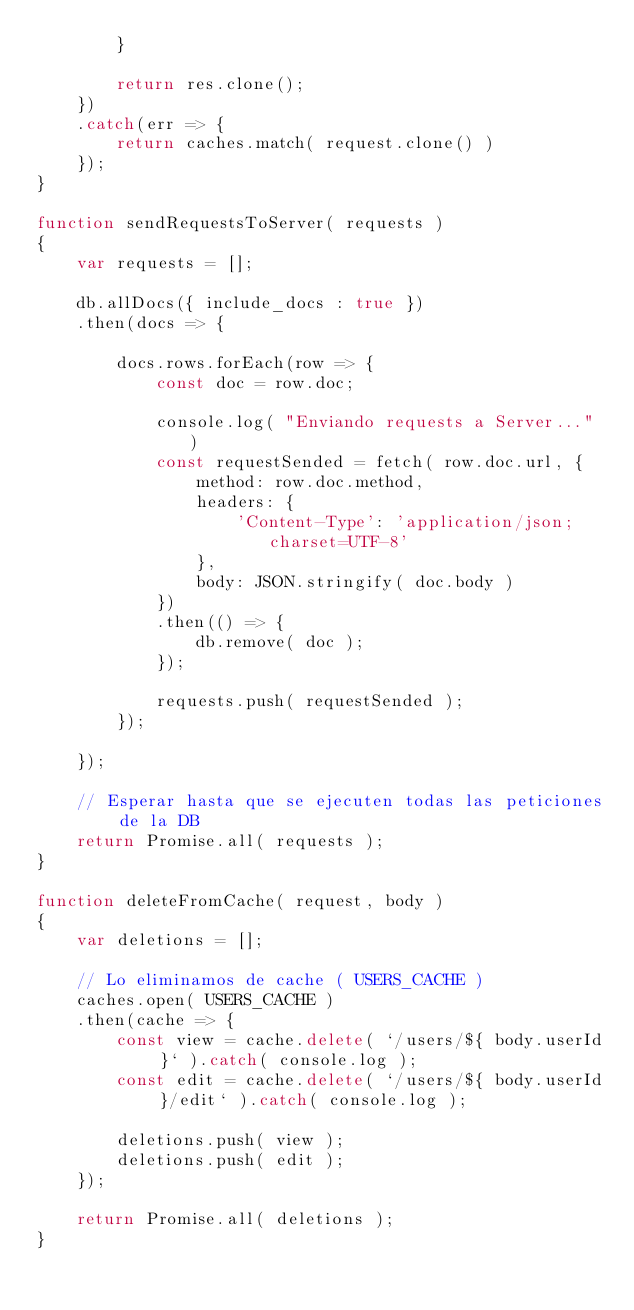Convert code to text. <code><loc_0><loc_0><loc_500><loc_500><_JavaScript_>        }

        return res.clone();
    })
    .catch(err => {
        return caches.match( request.clone() )
    });
}

function sendRequestsToServer( requests )
{
    var requests = [];

    db.allDocs({ include_docs : true })
    .then(docs => {
                
        docs.rows.forEach(row => {
            const doc = row.doc;

            console.log( "Enviando requests a Server..." )
            const requestSended = fetch( row.doc.url, {
                method: row.doc.method,
                headers: {
                    'Content-Type': 'application/json;charset=UTF-8'
                },
                body: JSON.stringify( doc.body )
            })
            .then(() => {
                db.remove( doc );
            });

            requests.push( requestSended );
        });

    });

    // Esperar hasta que se ejecuten todas las peticiones de la DB
    return Promise.all( requests );
}

function deleteFromCache( request, body )
{
    var deletions = [];

    // Lo eliminamos de cache ( USERS_CACHE )
    caches.open( USERS_CACHE )
    .then(cache => {
        const view = cache.delete( `/users/${ body.userId }` ).catch( console.log );
        const edit = cache.delete( `/users/${ body.userId }/edit` ).catch( console.log );
        
        deletions.push( view );
        deletions.push( edit );
    });

    return Promise.all( deletions );
}</code> 